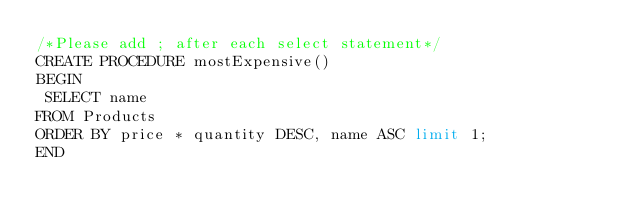Convert code to text. <code><loc_0><loc_0><loc_500><loc_500><_SQL_>/*Please add ; after each select statement*/
CREATE PROCEDURE mostExpensive()
BEGIN
 SELECT name
FROM Products 
ORDER BY price * quantity DESC, name ASC limit 1;
END</code> 